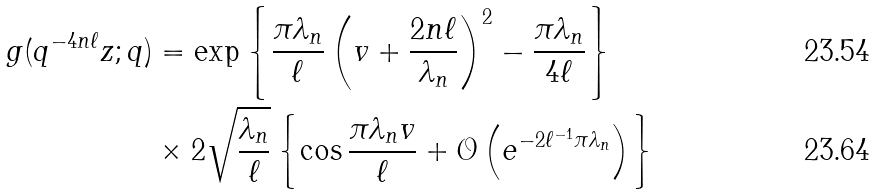Convert formula to latex. <formula><loc_0><loc_0><loc_500><loc_500>g ( q ^ { - 4 n \ell } z ; q ) & = \exp \left \{ \frac { \pi \lambda _ { n } } { \ell } \left ( v + \frac { 2 n \ell } { \lambda _ { n } } \right ) ^ { 2 } - \frac { \pi \lambda _ { n } } { 4 \ell } \right \} \\ & \times 2 \sqrt { \frac { \lambda _ { n } } { \ell } } \left \{ \cos \frac { \pi \lambda _ { n } v } { \ell } + \mathcal { O } \left ( e ^ { - 2 \ell ^ { - 1 } \pi \lambda _ { n } } \right ) \right \}</formula> 